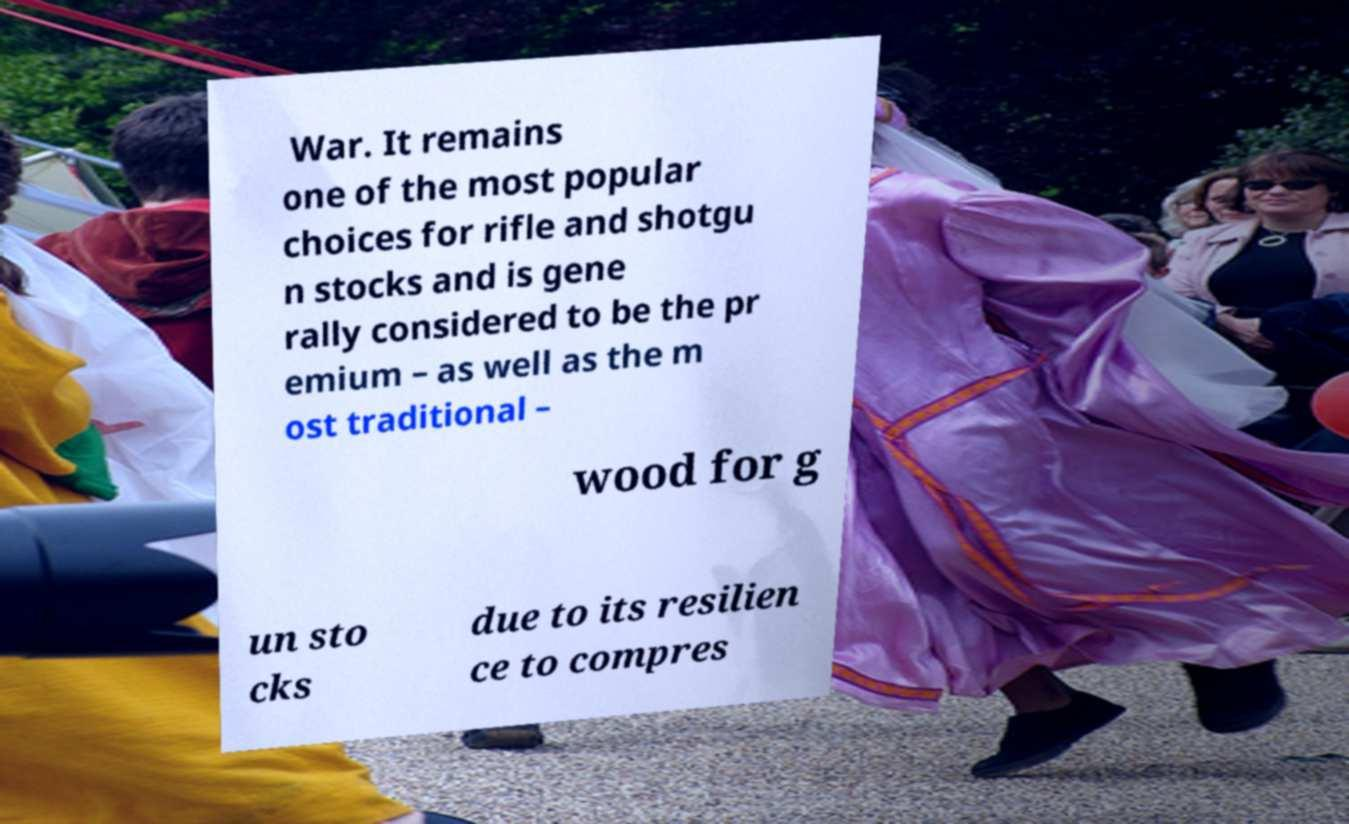For documentation purposes, I need the text within this image transcribed. Could you provide that? War. It remains one of the most popular choices for rifle and shotgu n stocks and is gene rally considered to be the pr emium – as well as the m ost traditional – wood for g un sto cks due to its resilien ce to compres 